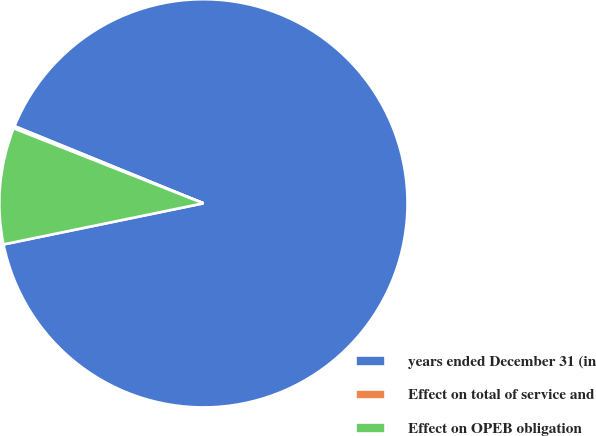Convert chart to OTSL. <chart><loc_0><loc_0><loc_500><loc_500><pie_chart><fcel>years ended December 31 (in<fcel>Effect on total of service and<fcel>Effect on OPEB obligation<nl><fcel>90.6%<fcel>0.18%<fcel>9.22%<nl></chart> 